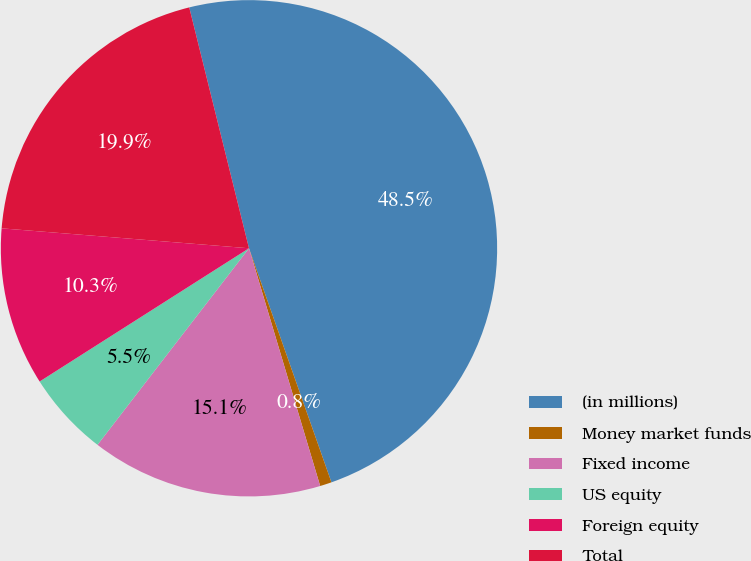Convert chart to OTSL. <chart><loc_0><loc_0><loc_500><loc_500><pie_chart><fcel>(in millions)<fcel>Money market funds<fcel>Fixed income<fcel>US equity<fcel>Foreign equity<fcel>Total<nl><fcel>48.48%<fcel>0.76%<fcel>15.08%<fcel>5.53%<fcel>10.3%<fcel>19.85%<nl></chart> 